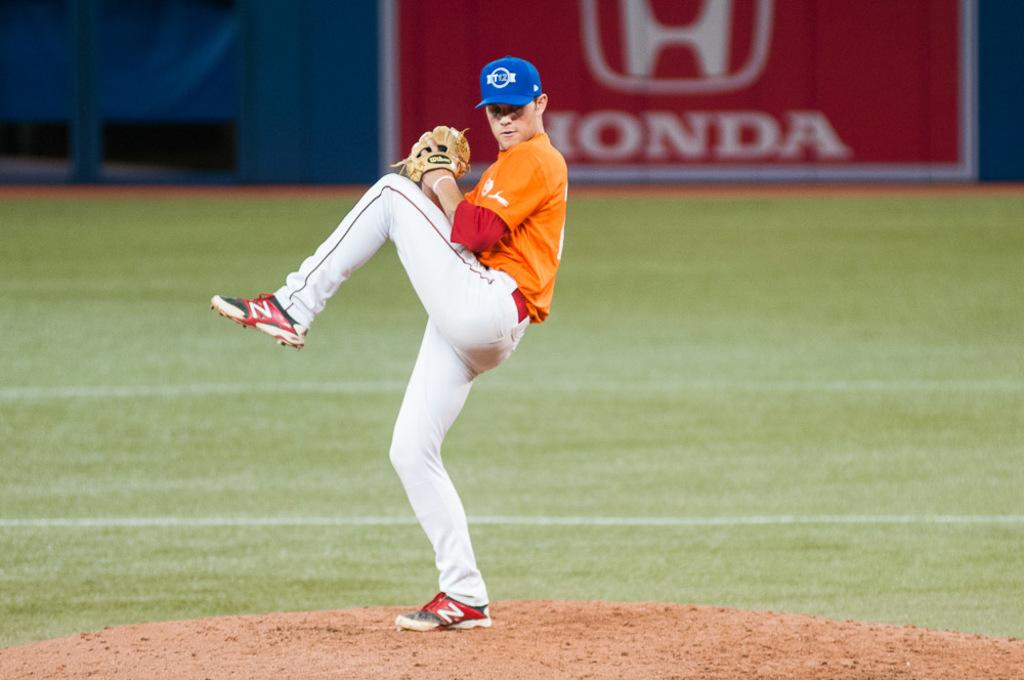<image>
Create a compact narrative representing the image presented. A pitcher prepares to throw the ball in front of a big red Honda sign. 